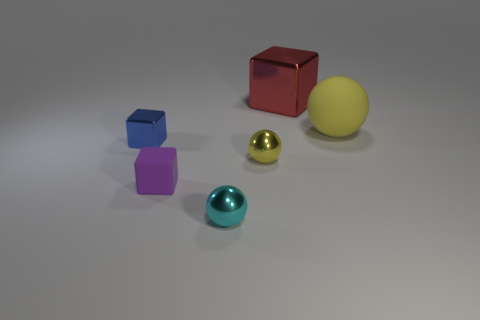Add 3 big purple rubber objects. How many objects exist? 9 Subtract 0 green blocks. How many objects are left? 6 Subtract all big cyan balls. Subtract all small yellow balls. How many objects are left? 5 Add 1 big red shiny blocks. How many big red shiny blocks are left? 2 Add 5 small yellow cubes. How many small yellow cubes exist? 5 